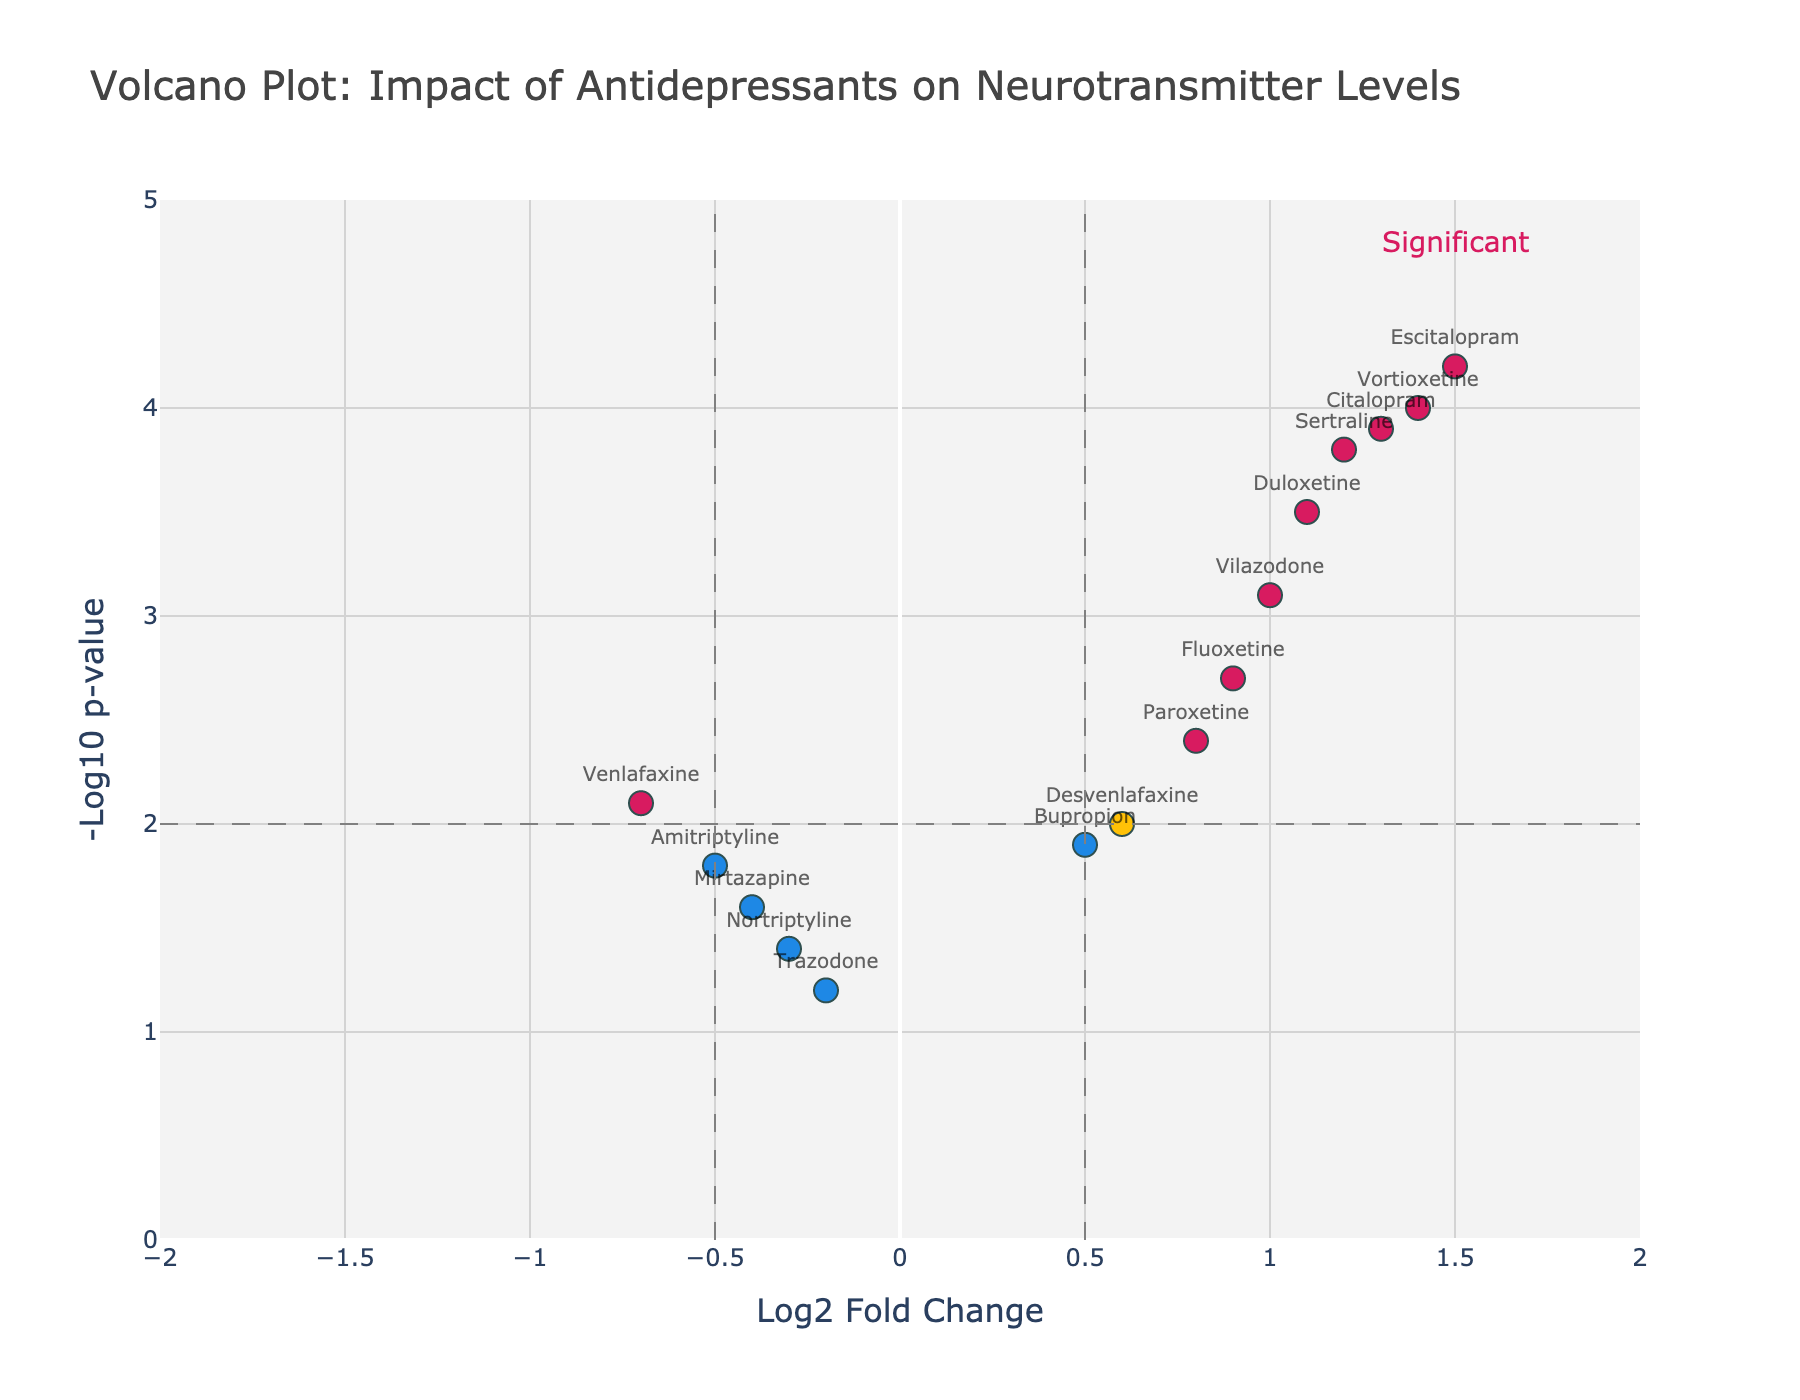What's the title of the plot? The title is located at the top of the plot and provides a summary of what the figure is about.
Answer: Volcano Plot: Impact of Antidepressants on Neurotransmitter Levels How many drugs have both a Log2FoldChange greater than 0.5 and a -Log10 p-value greater than 2.0? Identify the points on the plot that are colored in the significant color (which represents the threshold), and count them. Sertraline, Escitalopram, Duloxetine, Citalopram, Vilazodone, and Vortioxetine meet these criteria.
Answer: 6 Which drug has the highest -Log10 p-value? Look at the y-axis (which represents the -Log10 p-value) and identify the point that is the highest, then check its label.
Answer: Escitalopram What is the Log2FoldChange for Venlafaxine? Locate Venlafaxine on the plot and identify its position on the x-axis (Log2FoldChange).
Answer: -0.7 Which drugs have a negative Log2FoldChange? Identify points on the plot that are located to the left of the origin (negative x-axis) and check their labels.
Answer: Venlafaxine, Mirtazapine, Trazodone, Amitriptyline, Nortriptyline Compare the Log2FoldChange between Sertraline and Duloxetine, which one is higher? Look at the position of both Sertraline and Duloxetine on the x-axis and compare their Log2FoldChange values.
Answer: Sertraline Among the drugs with positive Log2FoldChange, which one has the lowest -Log10 p-value? Identify all drugs with positive Log2FoldChange (right side of the vertical line at x=0) and find the one with the lowest position on the y-axis.
Answer: Bupropion How many drugs have both a Log2FoldChange less than -0.5 and a -Log10 p-value greater than 1.8? Find all points in the lower left quadrant with the criteria (Log2FoldChange < -0.5 and -Log10 p-value > 1.8) and count them. Targeted conditions are Venlafaxine and Amitriptyline.
Answer: 2 What are the thresholds used in the plot to determine significance? Identify the dashed lines used in the plot, one vertical at Log2FoldChange = 0.5 (both positive and negative) and a horizontal line at -Log10 p-value = 2.
Answer: Log2FoldChange = ±0.5 and -Log10 p-value = 2 